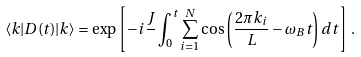<formula> <loc_0><loc_0><loc_500><loc_500>\langle { k } | D ( t ) | { k } \rangle = \exp \left [ - i \frac { J } { } \int _ { 0 } ^ { t } \sum _ { i = 1 } ^ { N } \cos \left ( \frac { 2 \pi k _ { i } } { L } - \omega _ { B } t \right ) d t \right ] \, .</formula> 